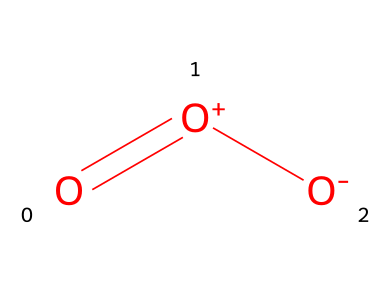how many oxygen atoms are in this molecule? The provided SMILES representation indicates the presence of three oxygen atoms, as seen in the arrangement "O=[O+][O-]", which clearly shows three instances of the letter O.
Answer: three what is the overall charge of this ozone molecule? In the SMILES representation, the presence of the positive charge on one oxygen atom and the negative charge on another indicates that the molecule has an overall neutral charge, as these charges cancel each other out.
Answer: neutral what type of bonding is present in this molecule? The structure shows a double bond between the central oxygen and one terminal oxygen, while single bonds are present to the other terminal oxygen. Therefore, it contains both double and single bonds.
Answer: double and single bonds what property allows ozone to purify air? Ozone is an effective oxidizer, which means its high reactivity enables it to oxidize pollutants and pathogens in the air, breaking them down into less harmful substances.
Answer: high reactivity how does ozone's molecular arrangement influence its function as an oxidizer? The unique arrangement of ozone, with its triatomic structure and the polarization of charges, allows it to readily react with various organic and inorganic substances, enhancing its effectiveness as an oxidizer for air purification.
Answer: enhances reactivity which element primarily contributes to the molecule's oxidizing capability? The reactivity of this molecule primarily comes from the oxygen atoms, which are known for their strong oxidizing power due to their electronegativity and ability to accept electrons.
Answer: oxygen in what state of matter is ozone most commonly found at ambient conditions? At ambient conditions, ozone is typically found in a gaseous state, as it is a gas under standard temperature and pressure, contributing to its application in air purification systems.
Answer: gas 